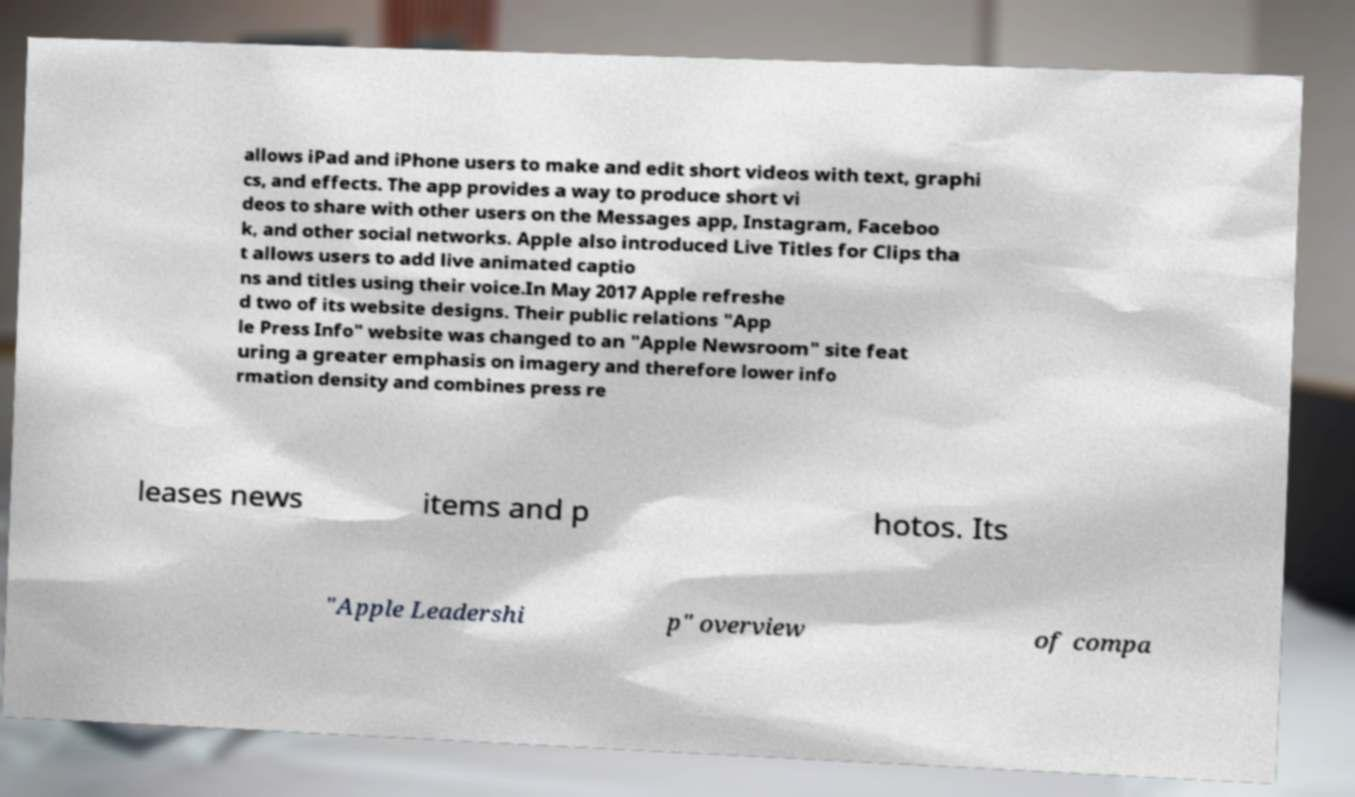Can you read and provide the text displayed in the image?This photo seems to have some interesting text. Can you extract and type it out for me? allows iPad and iPhone users to make and edit short videos with text, graphi cs, and effects. The app provides a way to produce short vi deos to share with other users on the Messages app, Instagram, Faceboo k, and other social networks. Apple also introduced Live Titles for Clips tha t allows users to add live animated captio ns and titles using their voice.In May 2017 Apple refreshe d two of its website designs. Their public relations "App le Press Info" website was changed to an "Apple Newsroom" site feat uring a greater emphasis on imagery and therefore lower info rmation density and combines press re leases news items and p hotos. Its "Apple Leadershi p" overview of compa 